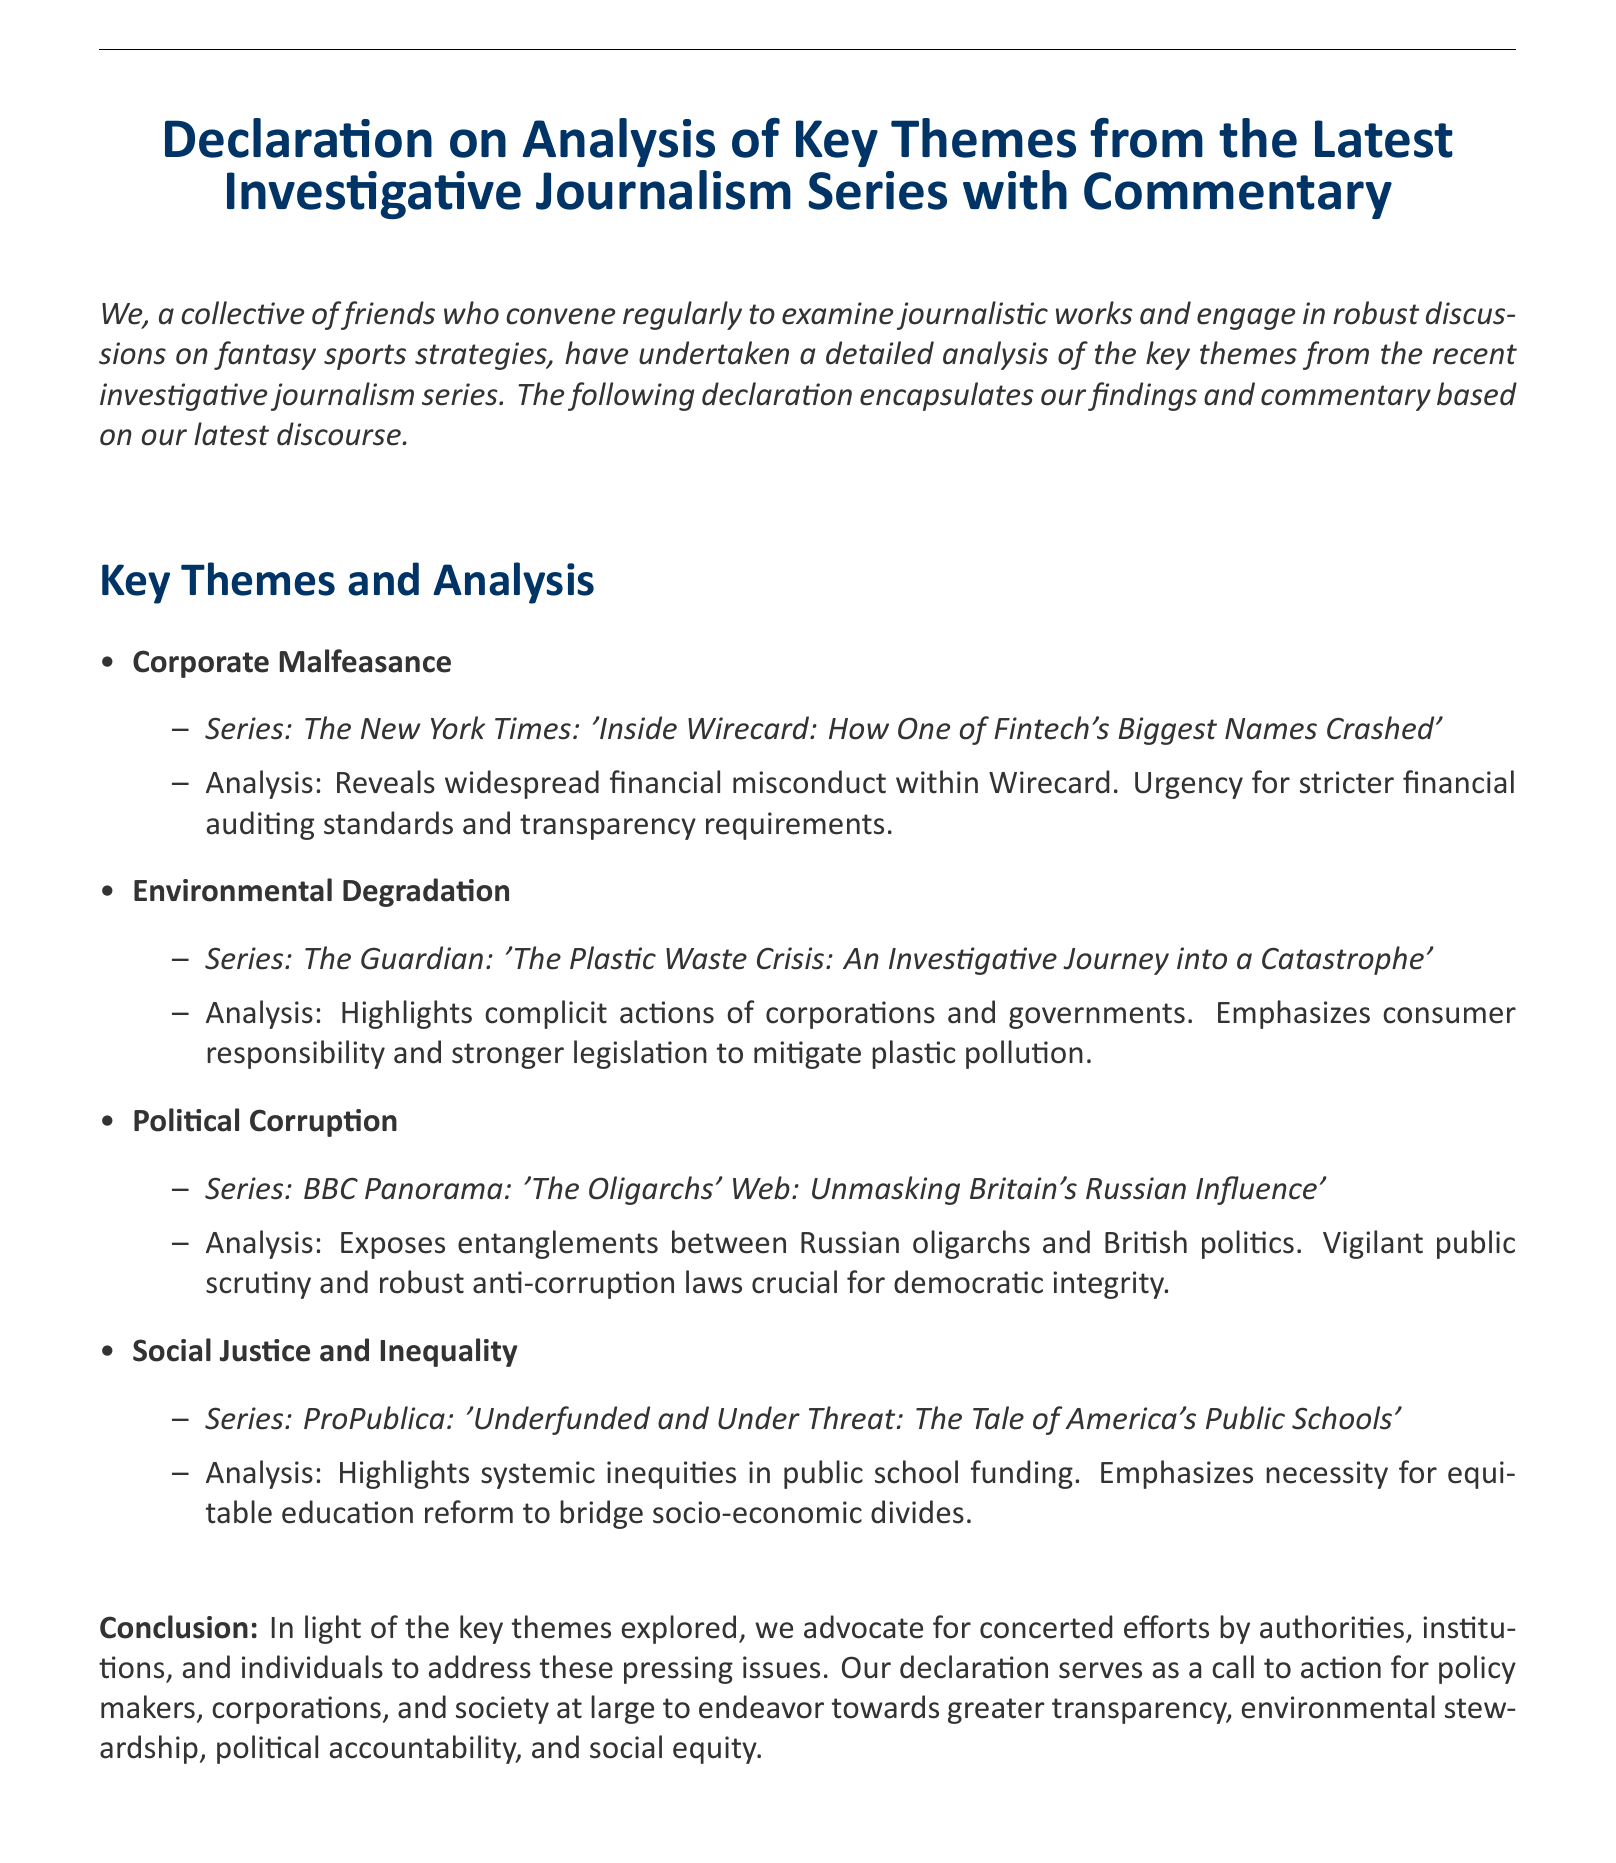what is the title of the document? The title is prominently displayed at the beginning of the document.
Answer: Declaration on Analysis of Key Themes from the Latest Investigative Journalism Series with Commentary how many key themes are analyzed? The number of key themes is identifiable in the list provided in the document.
Answer: Four which series discusses corporate malfeasance? This information can be found in the section related to corporate malfeasance.
Answer: The New York Times: 'Inside Wirecard: How One of Fintech's Biggest Names Crashed' what is emphasized in the environmental degradation analysis? The main emphasis can be found in the commentary regarding environmental issues.
Answer: Consumer responsibility and stronger legislation which organization reported on political corruption? The name of the organization is specified in the analysis of political corruption.
Answer: BBC Panorama what topic does the last analysis focus on? The final analysis clearly states its focus area towards the end of the key theme section.
Answer: Social Justice and Inequality what kind of action does the conclusion advocate for? The conclusion provides a clear call to action regarding certain issues addressed in the document.
Answer: Concerted efforts which publication highlighted issues in public schools? The publication is mentioned along with the title in the relevant analysis section.
Answer: ProPublica 